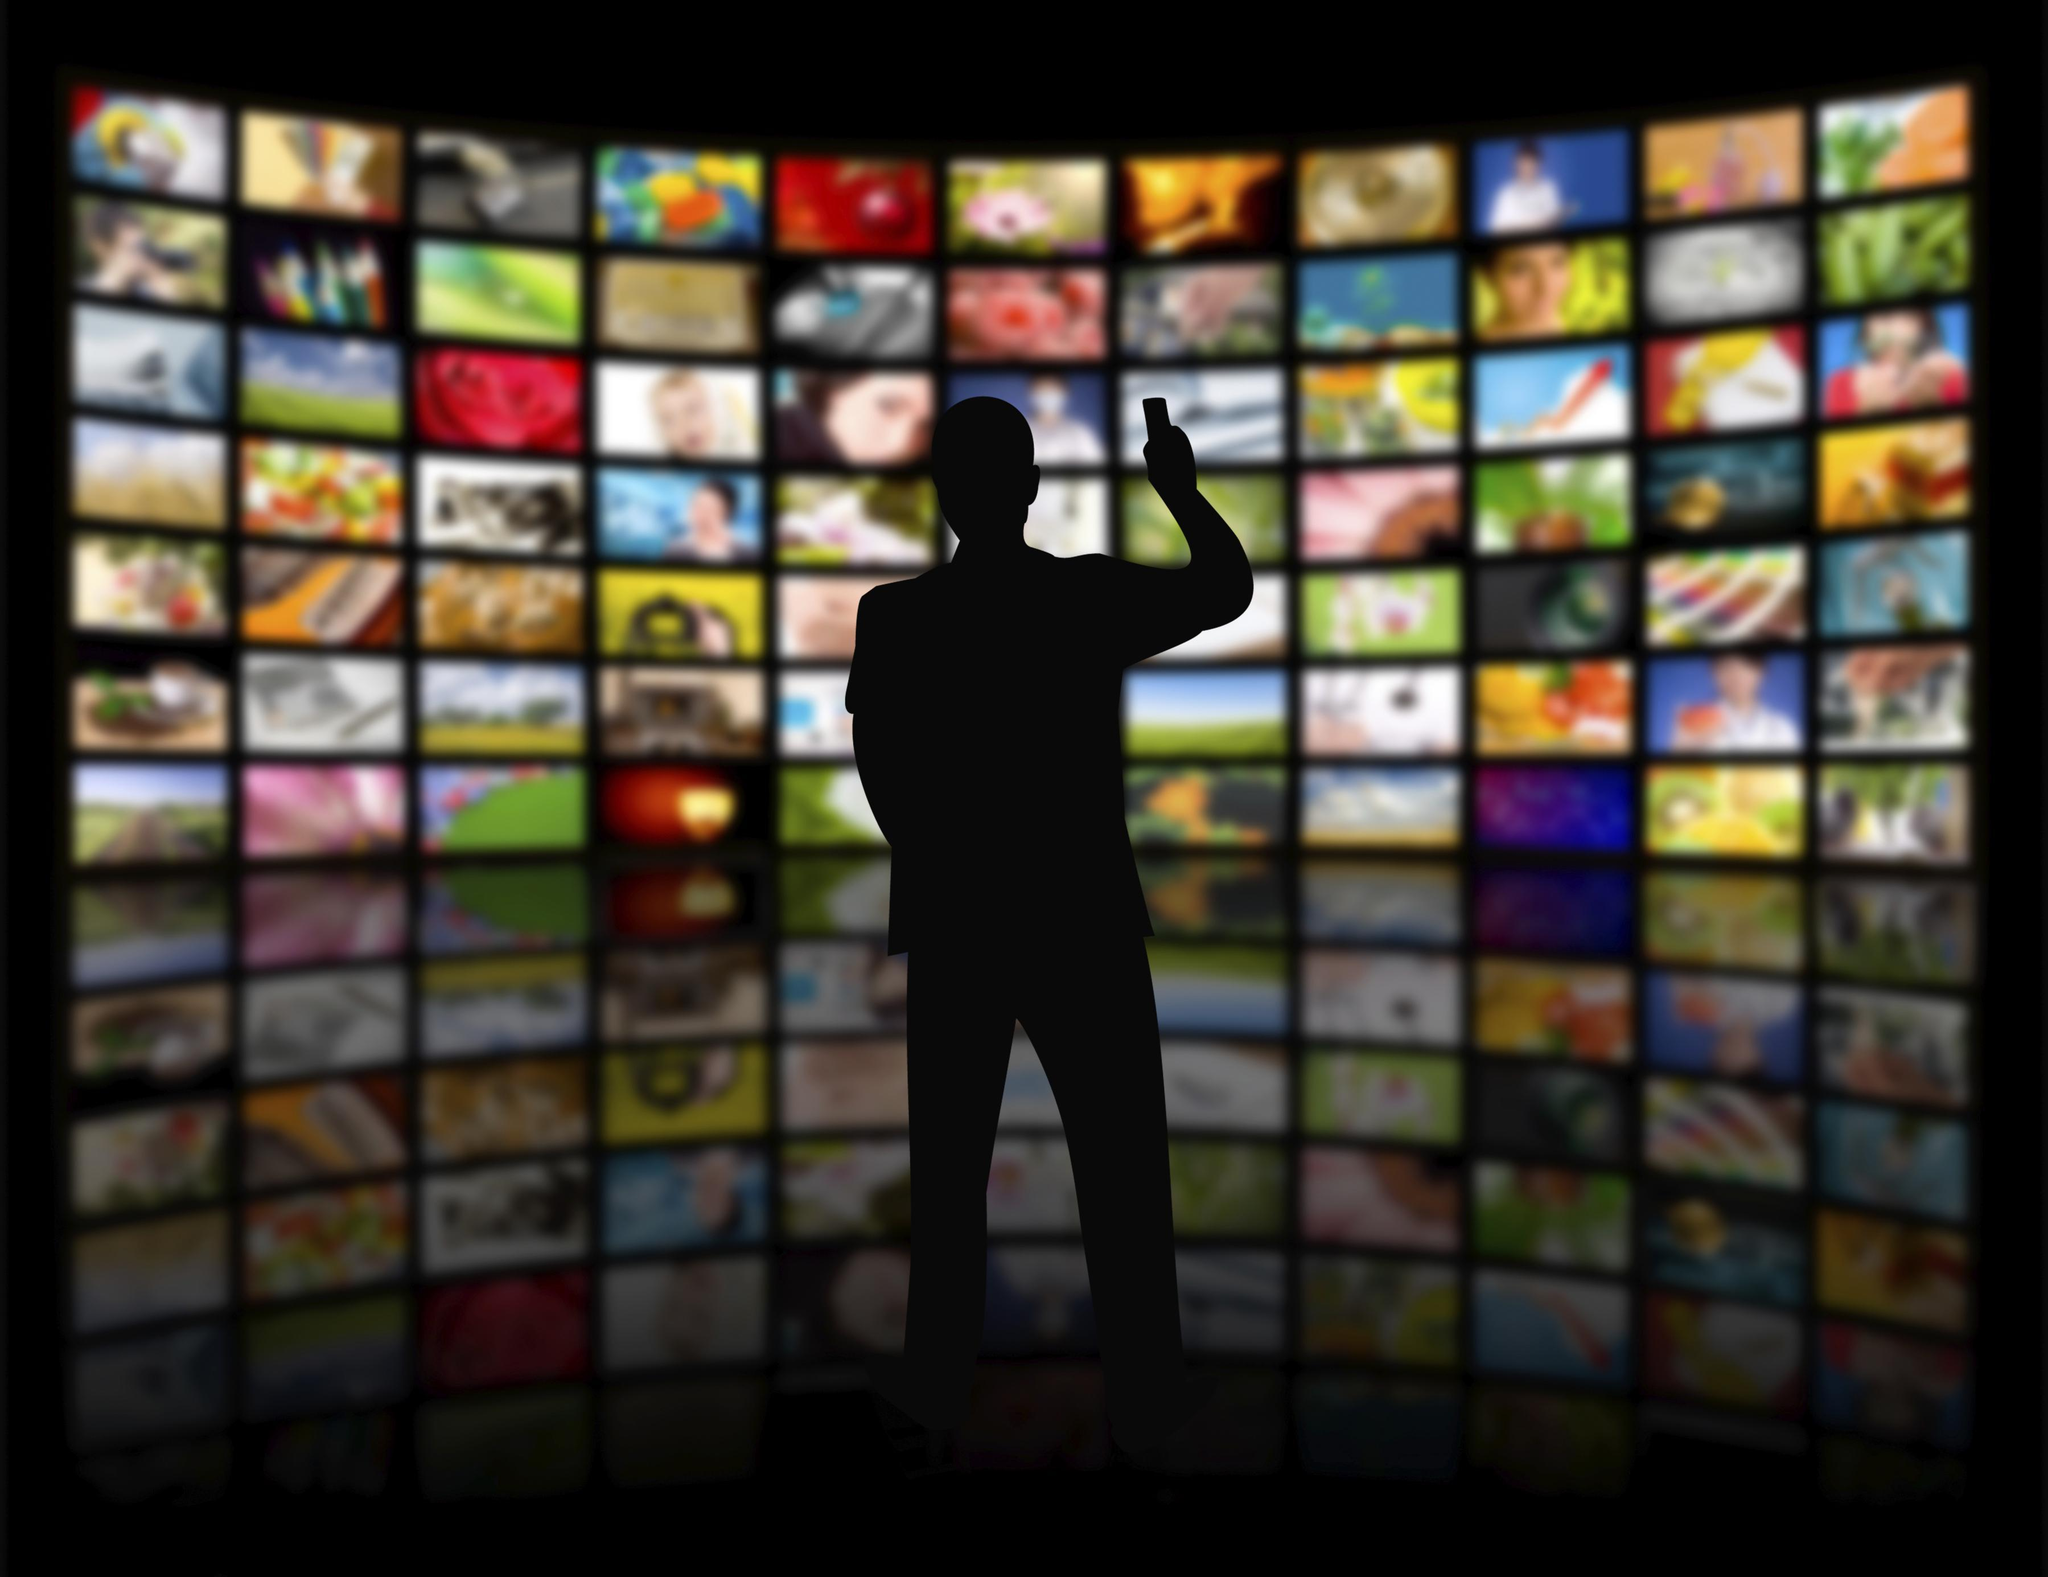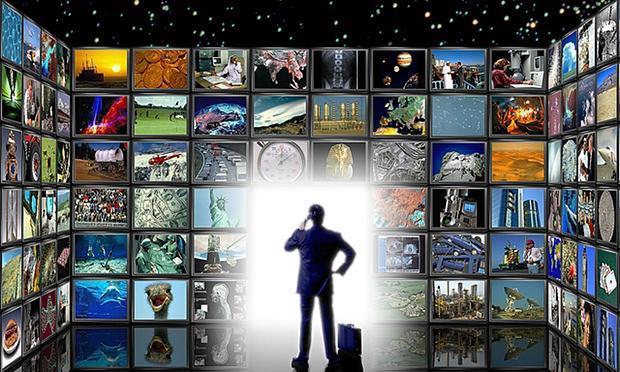The first image is the image on the left, the second image is the image on the right. For the images shown, is this caption "An image shows a silhouetted person surrounded by glowing white light and facing a wall of screens filled with pictures." true? Answer yes or no. Yes. The first image is the image on the left, the second image is the image on the right. Given the left and right images, does the statement "A person is standing in front of the screen in the image on the left." hold true? Answer yes or no. Yes. 